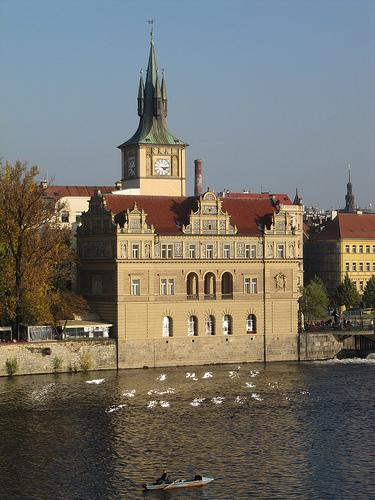Describe the overall composition of the image, focusing on the setting and its constituents. The image captures a waterfront setting filled with intriguing structures, such as buildings and trees, as people partake in various activities around the area. Comment on the natural and human-made elements present in the image. The image consists of natural elements like water and trees and human-made structures such as buildings and a clock tower near the water. Mention the primary type of structure seen in the image and its most distinct attributes. A large ornate building with a distinctive clock tower and detailed architectural elements near the water stands out. Briefly describe the recreational activities taking place in the scene and their connection to the surrounding environment. People enjoy outdoor pastimes near the water and large structures, including rowing a boat in the bustling surroundings. Provide a general description of the main elements present in the image. The image features white objects in water, people nearby, a large ornate building, and a tower with a green roof next to a tree. Describe the main built structures in the image and their relation to the surroundings. Prominent built structures include a large ornate building with a clock tower, all of which are located close to the water. Express the atmosphere of the image by highlighting the people's activities and the environment around them. The lively scene showcases individuals enjoying their time by the water, rowing a boat, against a picturesque background of unique buildings and greenery. Describe the activities taking place by the water in the image. People are seen rowing a boat amidst calm waters near the shore. Write a brief summary of the scene in the image, focusing on the most noticeable features. A scenic image reveals a large clock tower, ornate building near water, where people engage in various leisure activities under a large tree. 